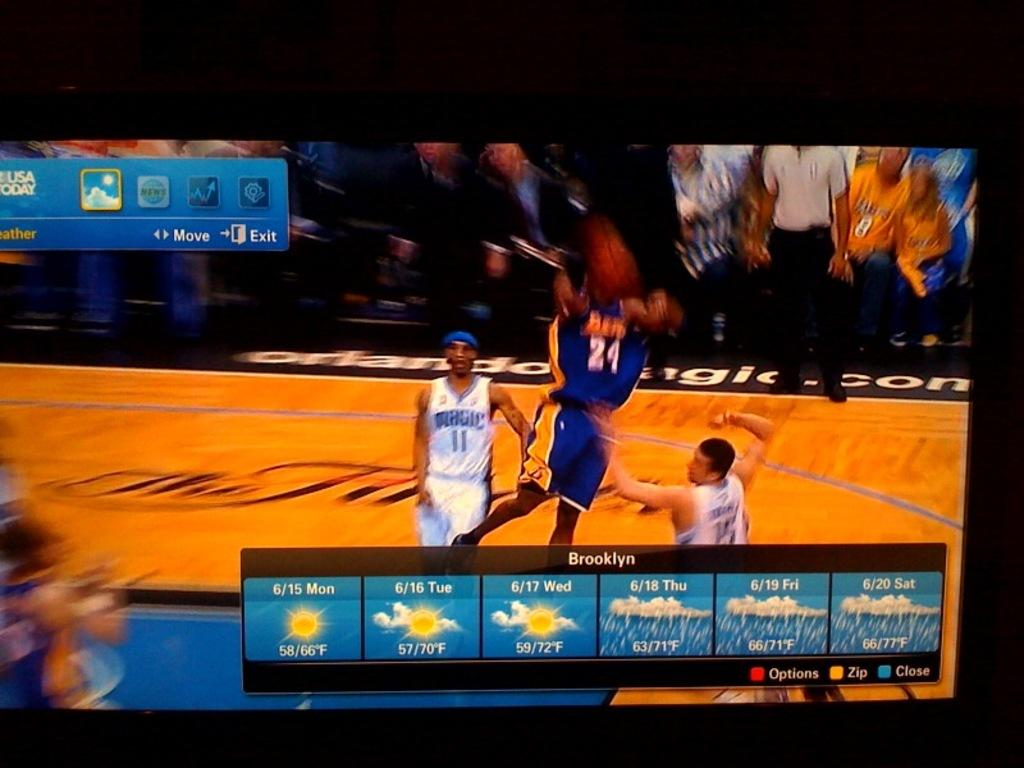<image>
Summarize the visual content of the image. A flat screen TV is showing a basketball game and the weather for Brooklyn. 